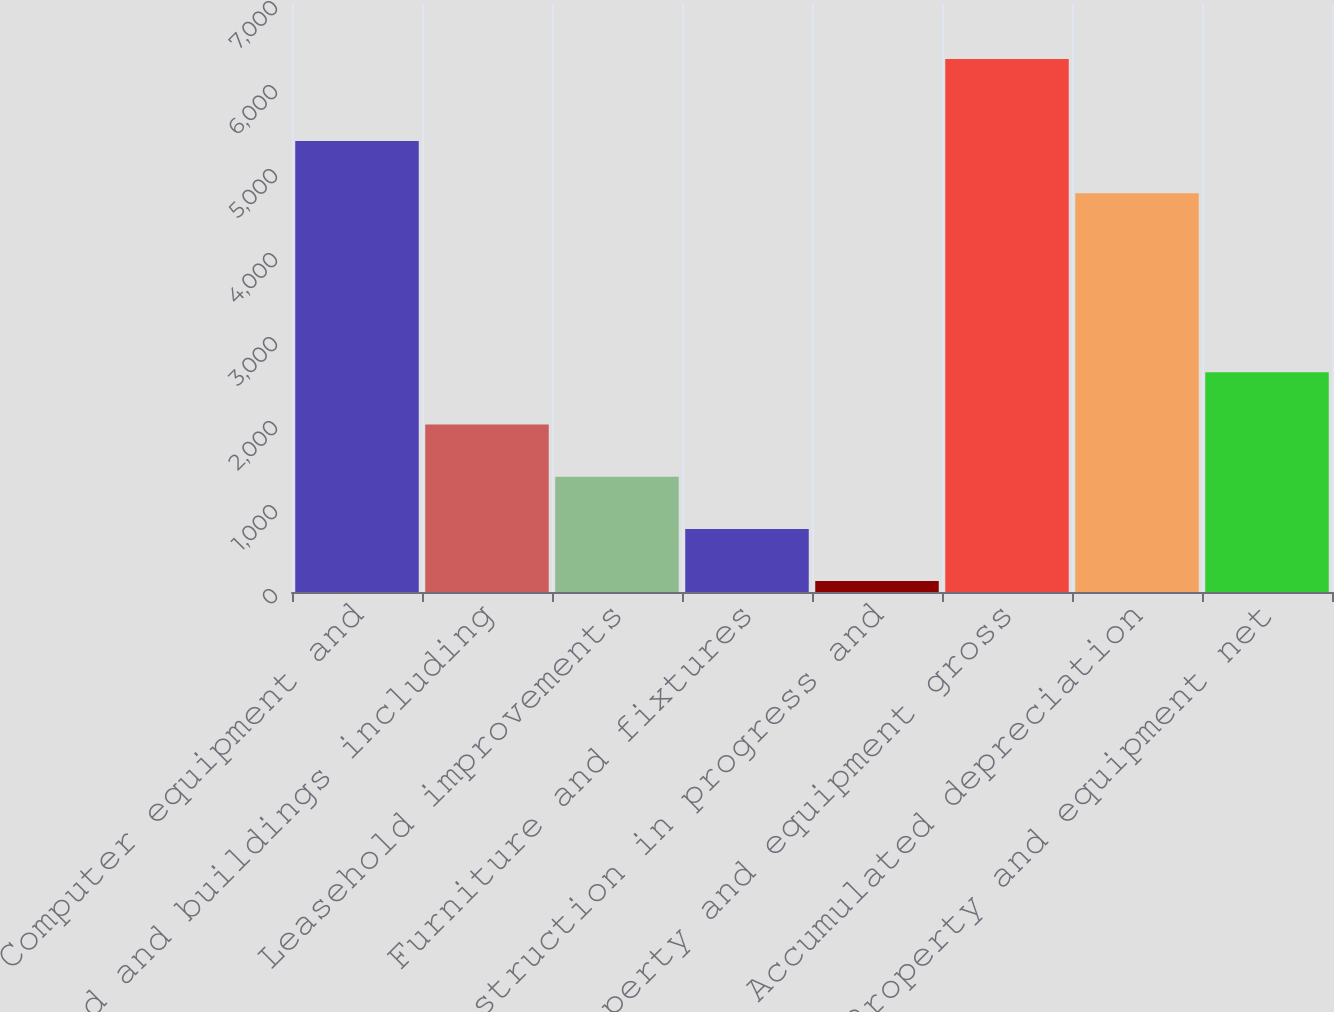Convert chart to OTSL. <chart><loc_0><loc_0><loc_500><loc_500><bar_chart><fcel>Computer equipment and<fcel>Land and buildings including<fcel>Leasehold improvements<fcel>Furniture and fixtures<fcel>Construction in progress and<fcel>Property and equipment gross<fcel>Accumulated depreciation<fcel>Property and equipment net<nl><fcel>5368.4<fcel>1994.2<fcel>1372.8<fcel>751.4<fcel>130<fcel>6344<fcel>4747<fcel>2615.6<nl></chart> 